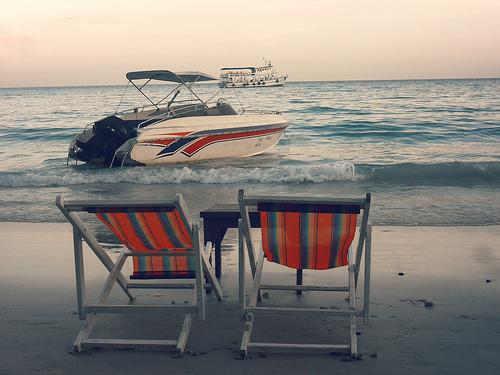Question: where is the table?
Choices:
A. Next to the fridge.
B. On the sidewalk.
C. In front of the chairs.
D. In the kitchen.
Answer with the letter. Answer: C Question: where is this scene?
Choices:
A. At the park.
B. A beach.
C. At a river.
D. In a amusement park.
Answer with the letter. Answer: B Question: how many tables are there?
Choices:
A. One.
B. Two.
C. Three.
D. Four.
Answer with the letter. Answer: A 